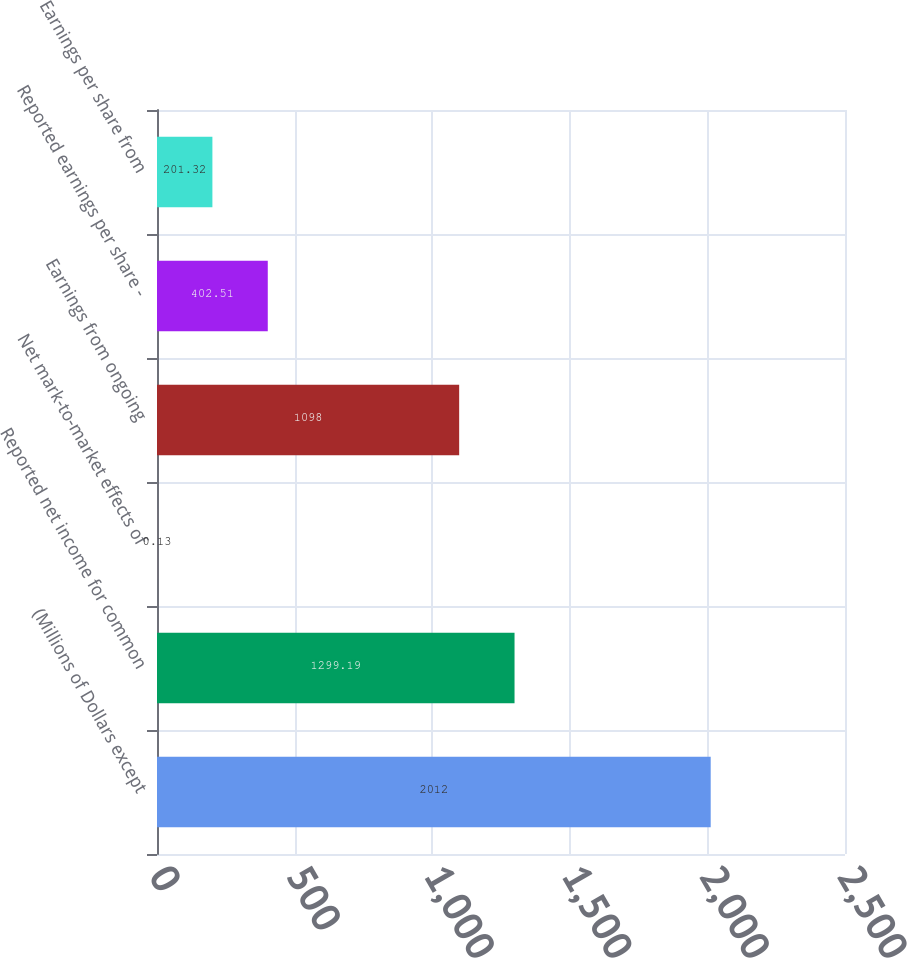Convert chart. <chart><loc_0><loc_0><loc_500><loc_500><bar_chart><fcel>(Millions of Dollars except<fcel>Reported net income for common<fcel>Net mark-to-market effects of<fcel>Earnings from ongoing<fcel>Reported earnings per share -<fcel>Earnings per share from<nl><fcel>2012<fcel>1299.19<fcel>0.13<fcel>1098<fcel>402.51<fcel>201.32<nl></chart> 